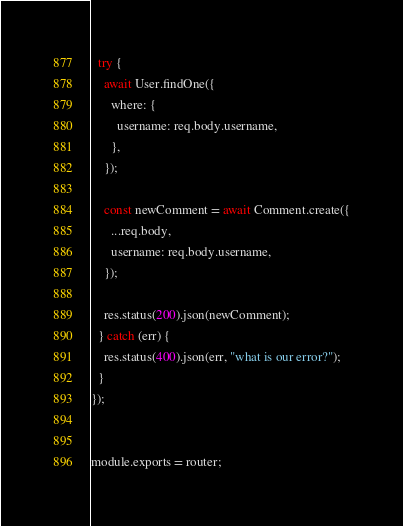Convert code to text. <code><loc_0><loc_0><loc_500><loc_500><_JavaScript_>  try {
    await User.findOne({
      where: {
        username: req.body.username,
      },
    });

    const newComment = await Comment.create({
      ...req.body,
      username: req.body.username,
    });

    res.status(200).json(newComment);
  } catch (err) {
    res.status(400).json(err, "what is our error?");
  }
});


module.exports = router;</code> 